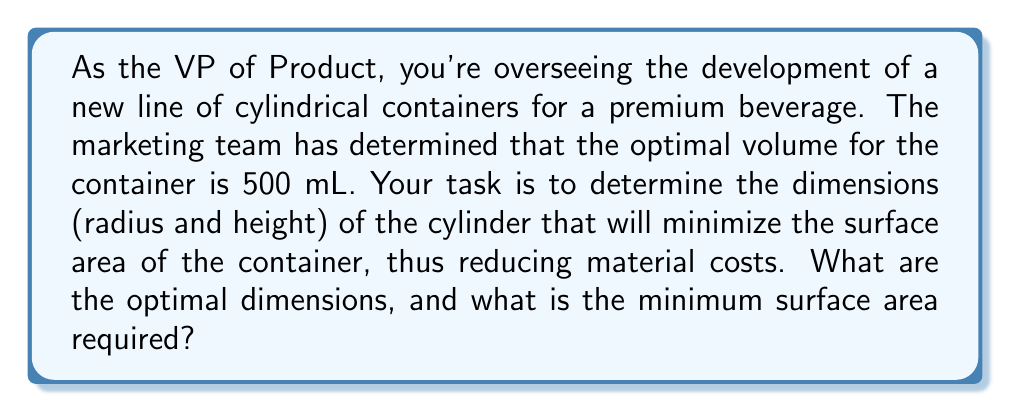Help me with this question. To solve this problem, we need to follow these steps:

1. Express the volume of the cylinder in terms of radius (r) and height (h):
   $$V = \pi r^2 h$$

2. Given that the volume is fixed at 500 mL (0.5 L), we can express h in terms of r:
   $$0.5 = \pi r^2 h$$
   $$h = \frac{0.5}{\pi r^2}$$

3. Express the surface area (SA) of the cylinder:
   $$SA = 2\pi r^2 + 2\pi rh$$

4. Substitute the expression for h into the surface area equation:
   $$SA = 2\pi r^2 + 2\pi r(\frac{0.5}{\pi r^2})$$
   $$SA = 2\pi r^2 + \frac{1}{r}$$

5. To find the minimum surface area, we need to differentiate SA with respect to r and set it to zero:
   $$\frac{dSA}{dr} = 4\pi r - \frac{1}{r^2} = 0$$

6. Solve this equation:
   $$4\pi r^3 = 1$$
   $$r^3 = \frac{1}{4\pi}$$
   $$r = \sqrt[3]{\frac{1}{4\pi}} \approx 0.0541 \text{ m}$$

7. Calculate the height using the expression from step 2:
   $$h = \frac{0.5}{\pi r^2} \approx 0.1082 \text{ m}$$

8. Calculate the minimum surface area:
   $$SA = 2\pi r^2 + 2\pi rh \approx 0.0555 \text{ m}^2$$

[asy]
import geometry;

real r = 5.41;
real h = 10.82;
real scale = 10;

path p = (0,0)--(r,0)--(r,h)--(0,h)--cycle;
path q = (r,0)--(r,h);
draw(p);
draw(q);
draw(arc((0,0),r,0,180));
draw(arc((0,h),r,180,360));

label("r", (r/2,0), S);
label("h", (r,h/2), E);
[/asy]
Answer: The optimal dimensions for the cylindrical container are:
Radius ≈ 5.41 cm
Height ≈ 10.82 cm
The minimum surface area required is approximately 555 cm². 